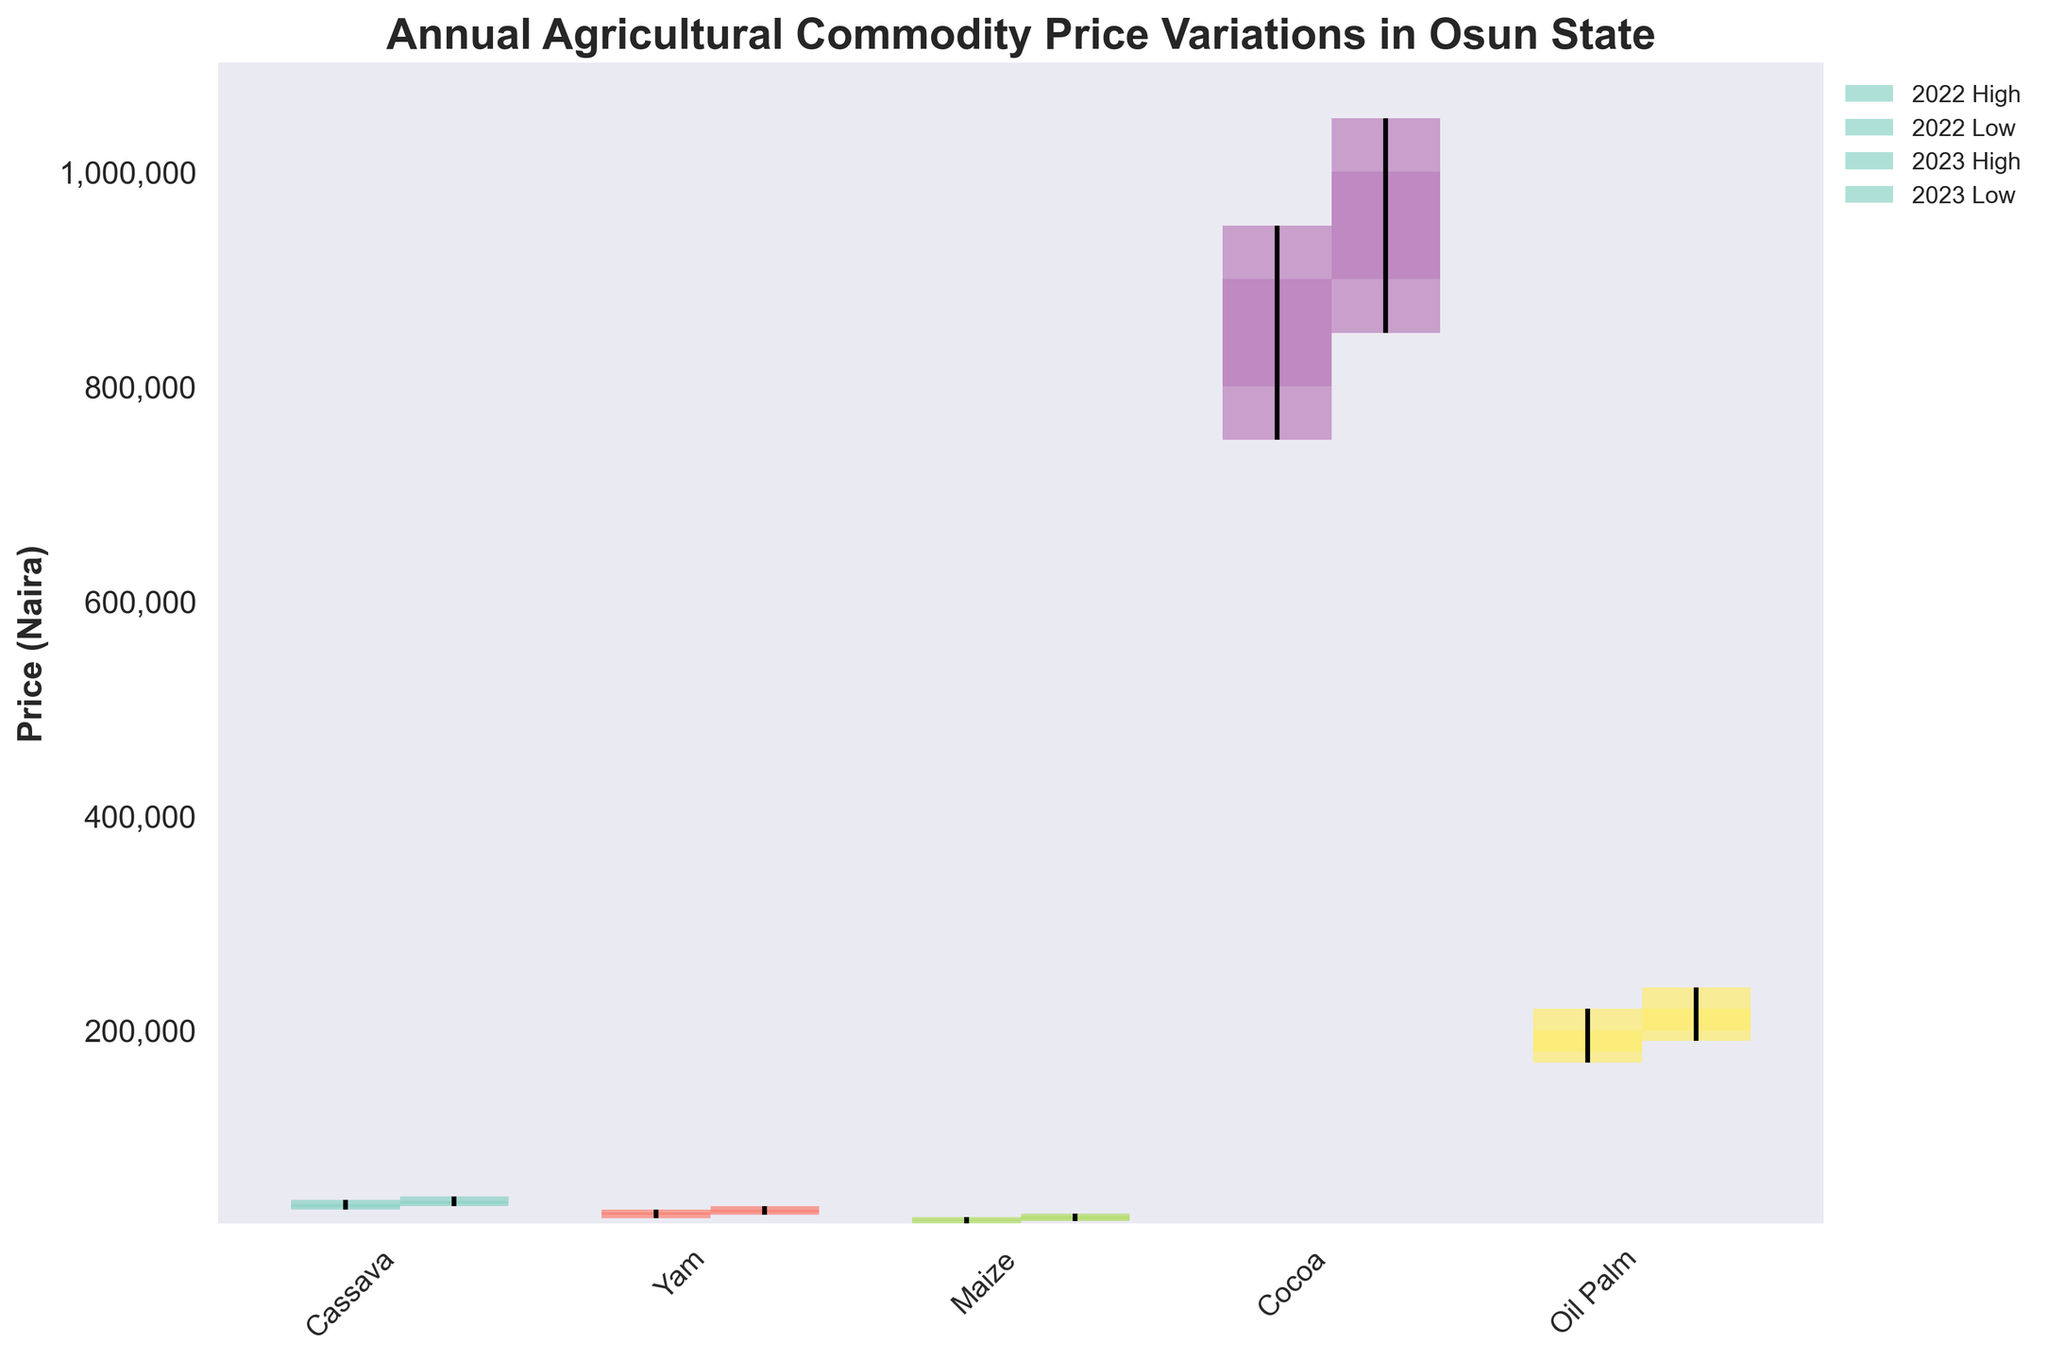What is the title of the figure? The title is typically located at the top of the figure and summarizes the main information represented.
Answer: Annual Agricultural Commodity Price Variations in Osun State How many crops are represented in the figure? By looking at the x-axis labels, you can count the unique crops stated.
Answer: 5 For the year 2022, what was the highest price recorded for Cocoa? Locate the bar labeled "Cocoa" for the year 2022 and read off the maximum value from the range.
Answer: 950,000 Which crop had the lowest price recorded in 2022? Compare the "Low" values of all crops for the year 2022 and find the minimum.
Answer: Maize What was the opening price of Oil Palm in 2023? Identify the bar for Oil Palm in the year 2023 and check the starting point of the bar.
Answer: 200,000 Did the closing price of Cassava increase or decrease from 2022 to 2023? Compare the closing prices labeled for Cassava in both years.
Answer: Increase Which crop had the largest difference between its highest and lowest prices in 2023? Calculate the difference (High - Low) for each crop in 2023 and compare the values.
Answer: Cocoa What was the overall price trend for Yam from its opening price in 2022 to its closing price in 2023? Check the opening price for Yam in 2022 and compare it to the closing price in 2023.
Answer: Increasing Based on the figure, which year had higher variability in Cocoa prices? Compare the range (High - Low) for Cocoa in both years and see which year has a larger range.
Answer: 2023 What is the price difference between the closing price of Maize in 2022 and its closing price in 2023? Subtract the closing price of Maize in 2022 from the closing price in 2023.
Answer: 3,000 